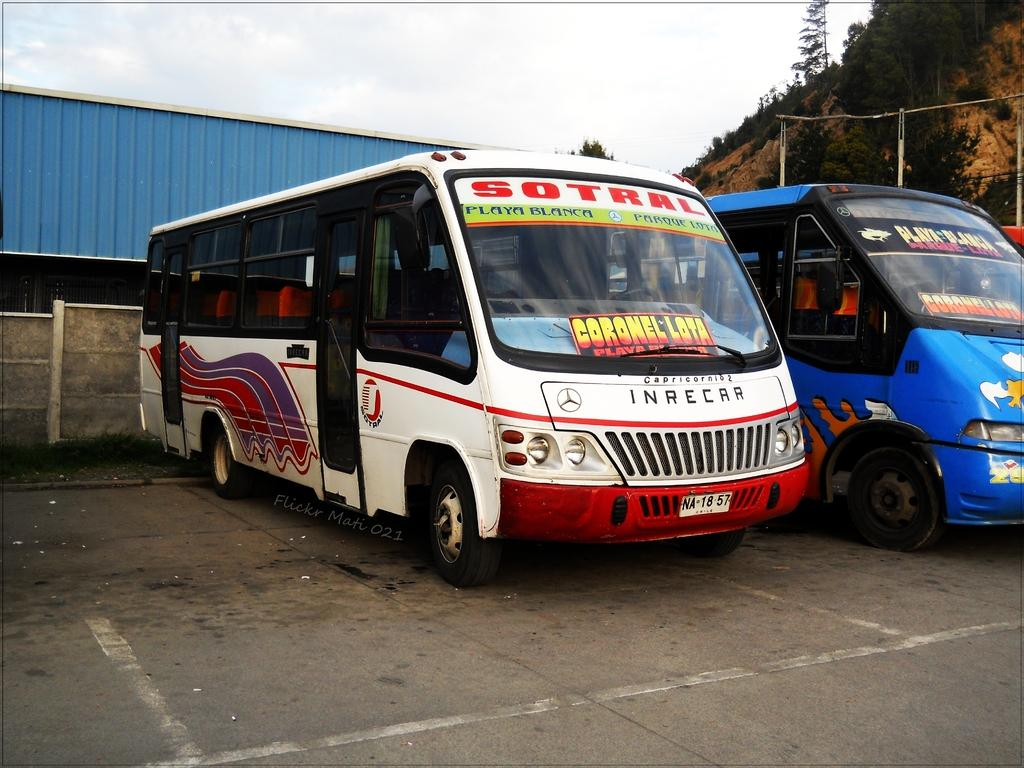What type of vehicles can be seen in the image? There are buses in the image. What is located behind the buses? There is a wall in the image. What type of natural elements are present in the image? There are trees and a hill in the image. What is visible above the buses and trees? The sky is visible in the image. Can you tell me how many cables are attached to the buses in the image? There are no cables attached to the buses in the image. What type of fruit is being used as a prop by the police officers in the image? There are no police officers or fruit present in the image. 